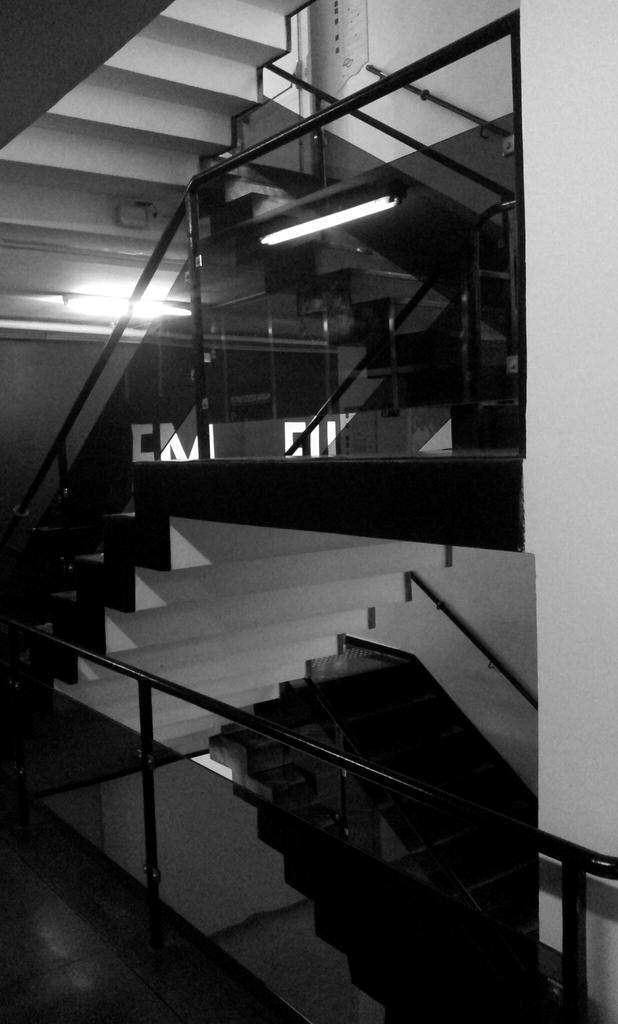What type of architectural feature is present in the image? There are steps in the image. What is located near the steps? There is fencing in the image. What can be seen on the steps in the image? There are lights on the steps. What type of suit can be seen hanging on the fencing in the image? There is no suit present in the image; it only features steps, fencing, and lights on the steps. Can you tell me where the church is located in the image? There is no church present in the image. 